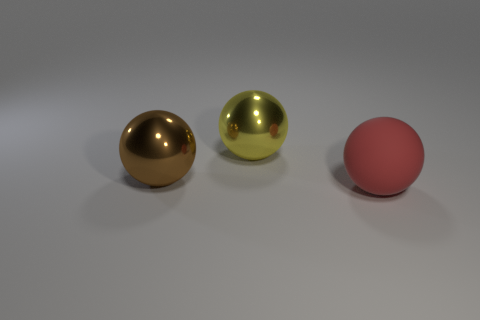Is there any other thing that is made of the same material as the red sphere?
Your answer should be compact. No. There is a big thing that is both behind the large red rubber ball and in front of the large yellow object; what color is it?
Offer a terse response. Brown. What number of large things are matte balls or yellow metallic cubes?
Keep it short and to the point. 1. There is a large yellow thing; what shape is it?
Give a very brief answer. Sphere. Are the large brown sphere and the thing behind the large brown object made of the same material?
Your response must be concise. Yes. What number of rubber things are either brown objects or large yellow spheres?
Your answer should be compact. 0. There is a shiny object right of the brown shiny sphere; how big is it?
Ensure brevity in your answer.  Large. The other ball that is the same material as the yellow ball is what size?
Offer a very short reply. Large. How many large rubber things have the same color as the big matte sphere?
Ensure brevity in your answer.  0. Are any big green rubber blocks visible?
Offer a terse response. No. 